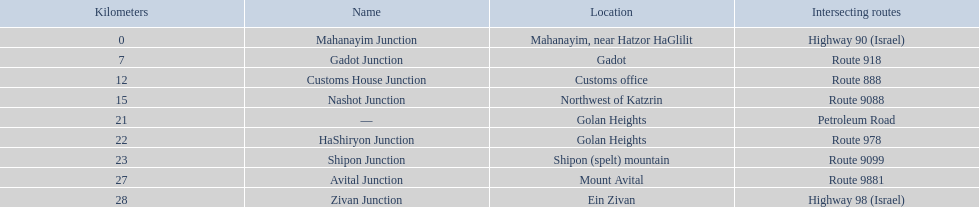Which junctions cross a route? Gadot Junction, Customs House Junction, Nashot Junction, HaShiryon Junction, Shipon Junction, Avital Junction. Which of these shares [art of its name with its locations name? Gadot Junction, Customs House Junction, Shipon Junction, Avital Junction. Which of them is not located in a locations named after a mountain? Gadot Junction, Customs House Junction. Which of these has the highest route number? Gadot Junction. 